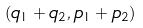<formula> <loc_0><loc_0><loc_500><loc_500>( q _ { 1 } + q _ { 2 } , p _ { 1 } + p _ { 2 } )</formula> 